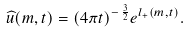<formula> <loc_0><loc_0><loc_500><loc_500>\widehat { u } ( m , t ) = ( 4 \pi t ) ^ { - \, \frac { 3 } { 2 } } e ^ { l _ { + } ( m , t ) } .</formula> 